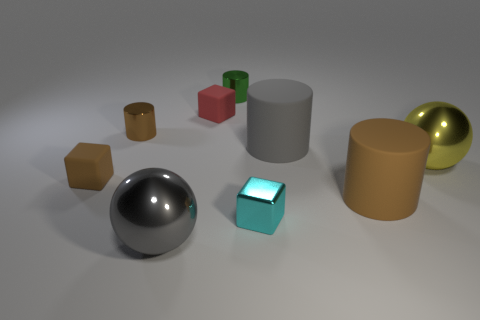Subtract all large brown rubber cylinders. How many cylinders are left? 3 Subtract all brown blocks. How many brown cylinders are left? 2 Add 1 big matte objects. How many objects exist? 10 Subtract 3 blocks. How many blocks are left? 0 Subtract all blocks. How many objects are left? 6 Subtract all yellow blocks. Subtract all yellow spheres. How many blocks are left? 3 Subtract all yellow things. Subtract all matte cylinders. How many objects are left? 6 Add 4 rubber things. How many rubber things are left? 8 Add 5 big gray blocks. How many big gray blocks exist? 5 Subtract all brown cubes. How many cubes are left? 2 